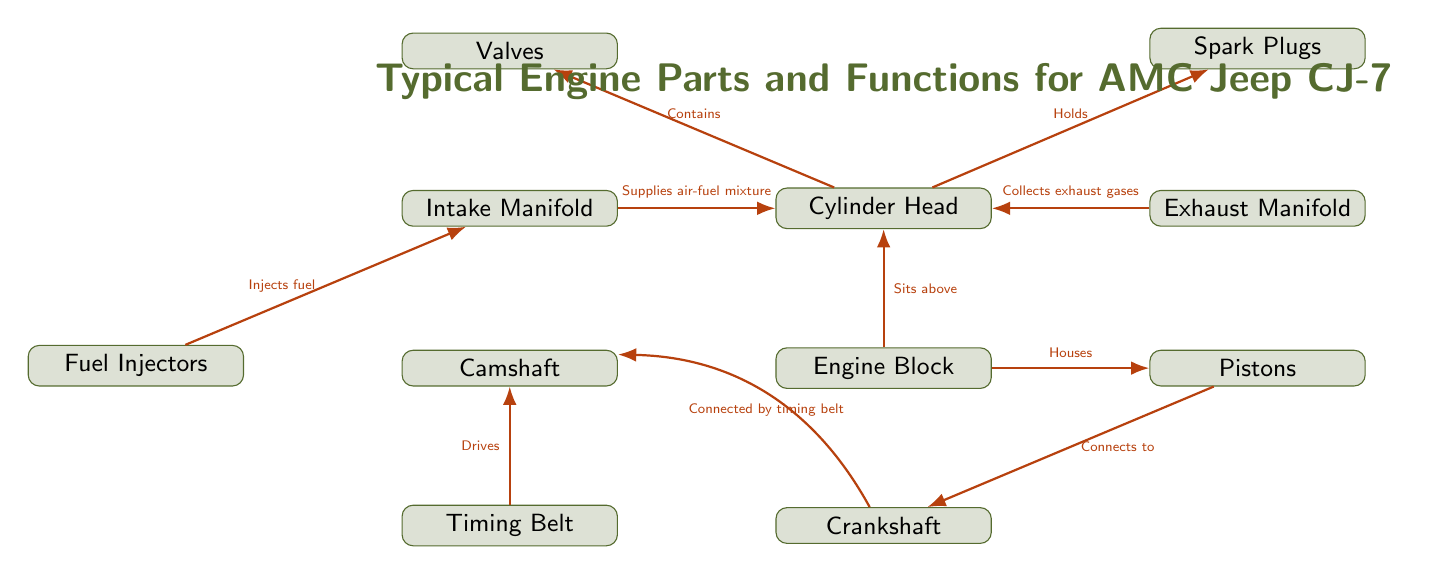What is the top component in the diagram? The diagram clearly shows the Cylinder Head positioned above the Engine Block, making it the topmost component depicted in the visual.
Answer: Cylinder Head How many engine parts are shown in the diagram? By counting all the distinct rectangles, we can see that there are a total of 10 engine parts illustrated in the diagram.
Answer: 10 What does the Timing Belt drive? The diagram indicates that the Timing Belt is connected to the Camshaft, which is the part it drives in the engine assembly.
Answer: Camshaft Which part contains the Spark Plugs? The connection line shows that the Cylinder Head holds or contains the Spark Plugs, as indicated by the directional arrow towards the Spark Plugs label.
Answer: Cylinder Head What supplies the air-fuel mixture? According to the diagram, the intake manifold is directly linked to the Cylinder Head, indicating it supplies the air-fuel mixture to that component.
Answer: Intake Manifold What connects the Pistons and the Crankshaft? The diagram explicitly states that the Pistons connect to the Crankshaft, indicating a direct relationship and function between these two parts.
Answer: Connects to Which part collects exhaust gases? From the diagram, the Exhaust Manifold is connected to the Cylinder Head, indicating that this part is responsible for collecting the exhaust gases.
Answer: Exhaust Manifold What role do Fuel Injectors serve? The connection from the Fuel Injectors going to the Intake Manifold specifies that their role is to inject fuel into the system.
Answer: Injects fuel Which part is below the Engine Block? The Crankshaft is depicted directly below the Engine Block in the diagram, establishing its positional relationship.
Answer: Crankshaft 